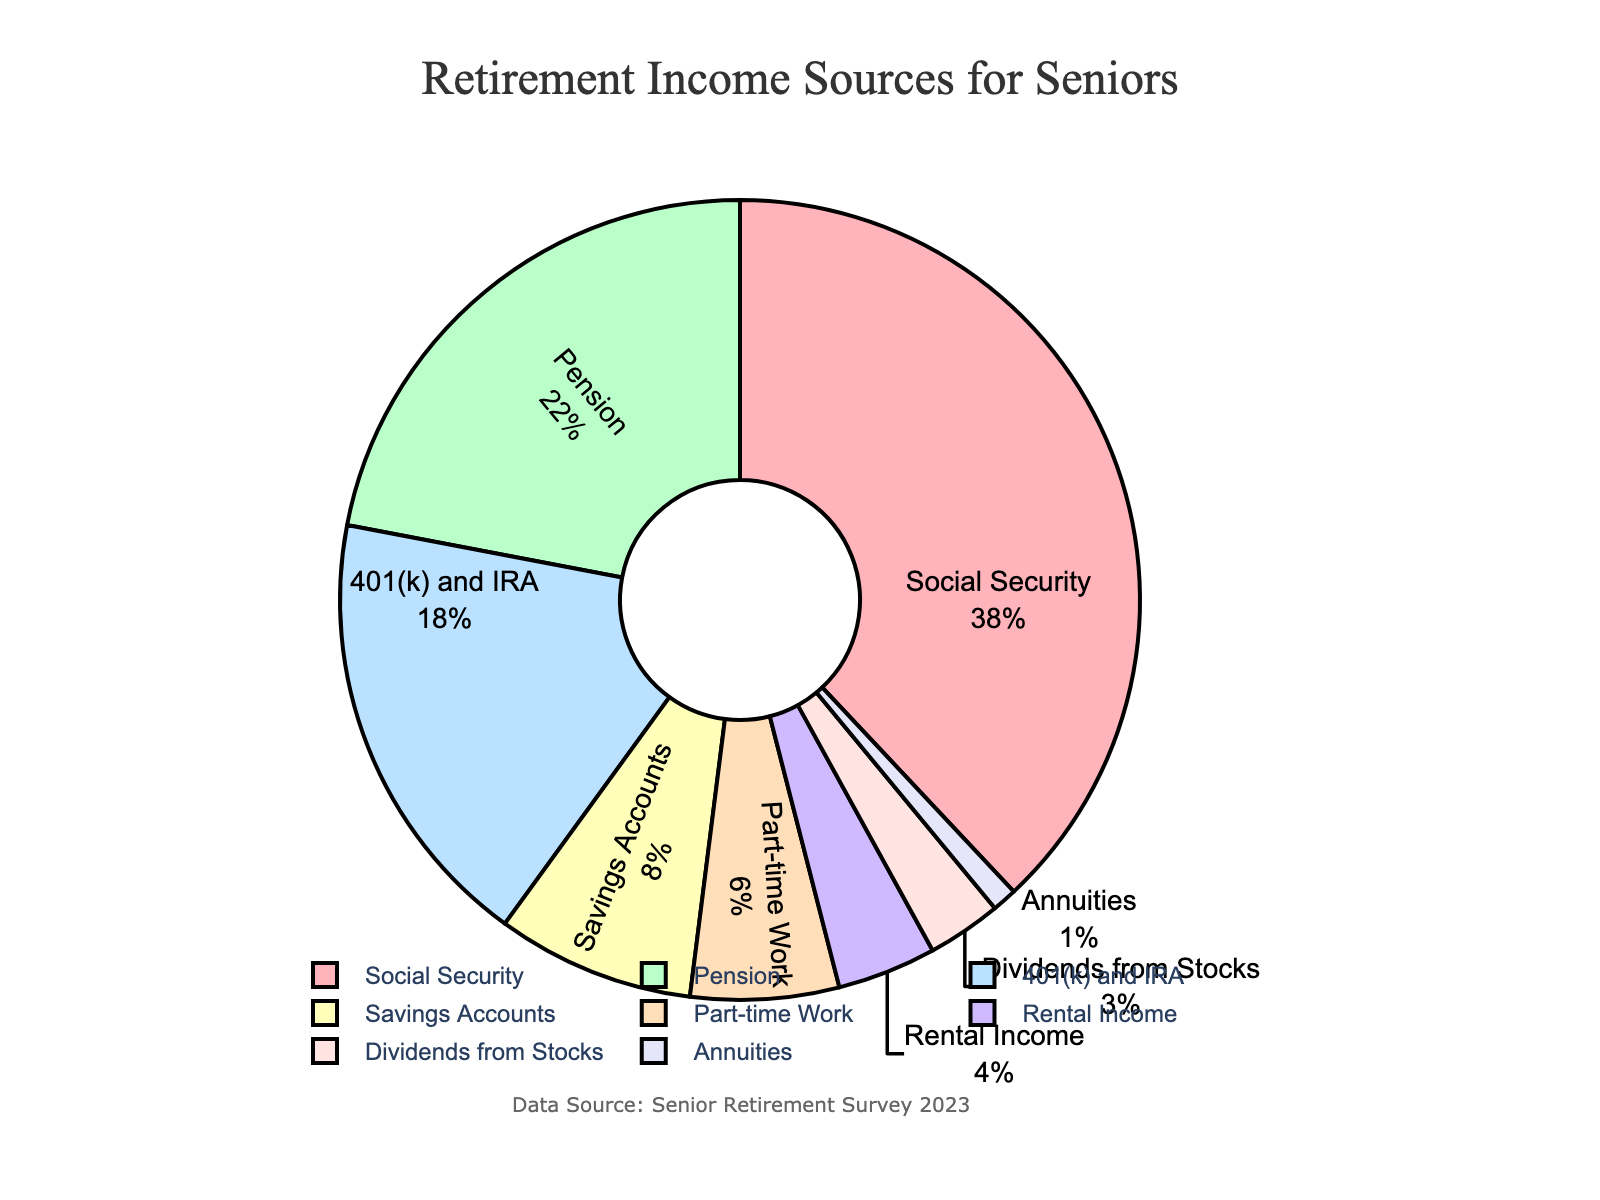What is the largest source of retirement income for seniors? The largest source is represented by the biggest slice of the pie chart. From the labels and percentages, Social Security, at 38%, is the largest source of retirement income for seniors.
Answer: Social Security Which two sources of income combined make up exactly half of the retirement income? To find the combination that makes up 50%, we add up the percentages. Social Security is 38% and Pension is 22%, so 38% + 22% = 60%. Including 401(k) and IRA (18%) would exceed 50%. So, the next highest sources after Social Security (38%) is 401(k) and IRA (18%), but their total is 56%, which is still higher than 50%. However, Savings Accounts (8%) and Part-time Work (6%) add up to another 14%, but this does not fit perfectly. Thus, no exact combination of two sources totals 50%.
Answer: None exactly What is the difference in percentage between the largest and the smallest sources of retirement income? From the pie chart, the largest source is Social Security at 38%, and the smallest source is Annuities at 1%. The difference is calculated by subtracting the smallest percentage from the largest: 38% - 1% = 37%.
Answer: 37% Which source of income has the third-highest percentage? By looking at the sizes of the slices and the labels, the third-highest percentage comes after Social Security (38%) and Pension (22%). The next highest is 401(k) and IRA at 18%.
Answer: 401(k) and IRA Compare the total percentage of income from Savings Accounts, Dividends from Stocks, and Annuities to the income from Pensions. Which one is higher? The total percentage of Savings Accounts (8%), Dividends from Stocks (3%), and Annuities (1%) is summed as 8% + 3% + 1% = 12%. Comparing this to the percentage from Pensions which is 22%, Pensions have a higher percentage of income.
Answer: Pensions Which slice on the pie chart is colored green and what percentage does it represent? The colors used in the pie chart can be determined by matching the segments to their descriptions. In this case, 'Pension' is colored green and represents 22% of the total income.
Answer: Pension, 22% If the sections for Part-time Work and Rental Income were combined into a single category, what percentage of the total retirement income would that new category represent? Adding the percentages from Part-time Work (6%) and Rental Income (4%) gives: 6% + 4% = 10%.
Answer: 10% What is the combined percentage of all sources of retirement income except for Social Security and Pension? Subtracting the percentages of Social Security (38%) and Pension (22%) from the total 100%, we get: 100% - 38% - 22% = 40%.
Answer: 40% How does the percentage from 401(k) and IRA compare to the combined percentage from Rental Income and Dividends from Stocks? The percentage from 401(k) and IRA is 18%. The combined percentage from Rental Income (4%) and Dividends from Stocks (3%) is 4% + 3% = 7%. Therefore, 401(k) and IRA (18%) is greater than the combined Rental Income and Dividends from Stocks (7%).
Answer: Greater What proportion of the retirement income comes from non-investment sources? Non-investment sources include Social Security, Pension, and Part-time Work: Social Security (38%), Pension (22%), and Part-time Work (6%). Summing these percentages: 38% + 22% + 6% = 66%.
Answer: 66% 